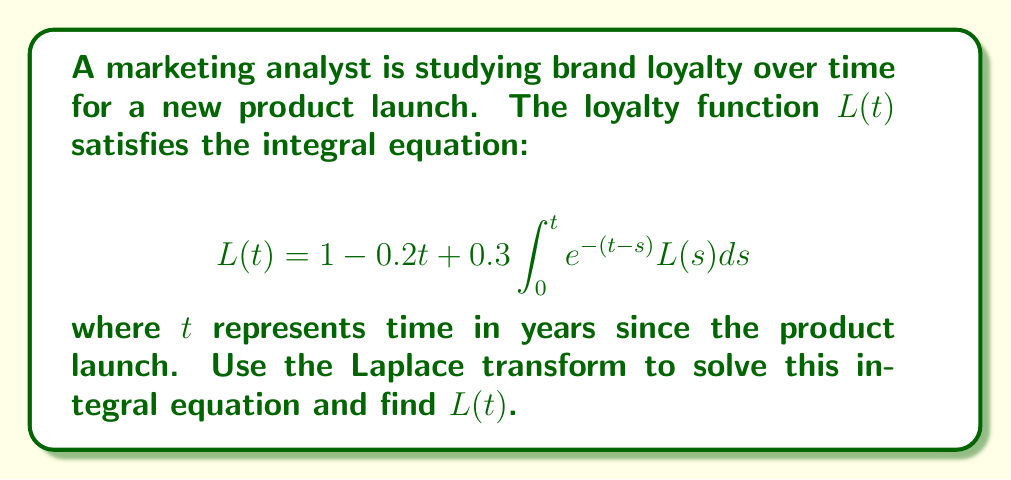Give your solution to this math problem. Let's solve this step-by-step using the Laplace transform:

1) Let $\mathcal{L}\{L(t)\} = F(s)$. Take the Laplace transform of both sides:

   $$\mathcal{L}\{L(t)\} = \mathcal{L}\{1 - 0.2t + 0.3\int_0^t e^{-(t-s)}L(s)ds\}$$

2) Using Laplace transform properties:

   $$F(s) = \frac{1}{s} - \frac{0.2}{s^2} + 0.3\mathcal{L}\{\int_0^t e^{-(t-s)}L(s)ds\}$$

3) The last term is a convolution integral. Its Laplace transform is the product of the Laplace transforms of the two functions:

   $$F(s) = \frac{1}{s} - \frac{0.2}{s^2} + 0.3 \cdot \frac{1}{s+1} \cdot F(s)$$

4) Simplify:

   $$F(s) = \frac{1}{s} - \frac{0.2}{s^2} + \frac{0.3F(s)}{s+1}$$

5) Multiply both sides by $(s+1)$:

   $$F(s)(s+1) = \frac{s+1}{s} - \frac{0.2(s+1)}{s^2} + 0.3F(s)$$

6) Rearrange:

   $$F(s)(s+0.7) = \frac{s+1}{s} - \frac{0.2(s+1)}{s^2}$$

7) Solve for $F(s)$:

   $$F(s) = \frac{s^2+s-0.2s-0.2}{s^2(s+0.7)} = \frac{s^2+0.8s-0.2}{s^2(s+0.7)}$$

8) Decompose into partial fractions:

   $$F(s) = \frac{A}{s} + \frac{B}{s^2} + \frac{C}{s+0.7}$$

   Solving for A, B, and C:

   $$F(s) = \frac{1}{s} + \frac{0.2857}{s^2} + \frac{1.4286}{s+0.7}$$

9) Take the inverse Laplace transform:

   $$L(t) = 1 + 0.2857t + 1.4286e^{-0.7t}$$

This is the solution to the integral equation.
Answer: $L(t) = 1 + 0.2857t + 1.4286e^{-0.7t}$ 